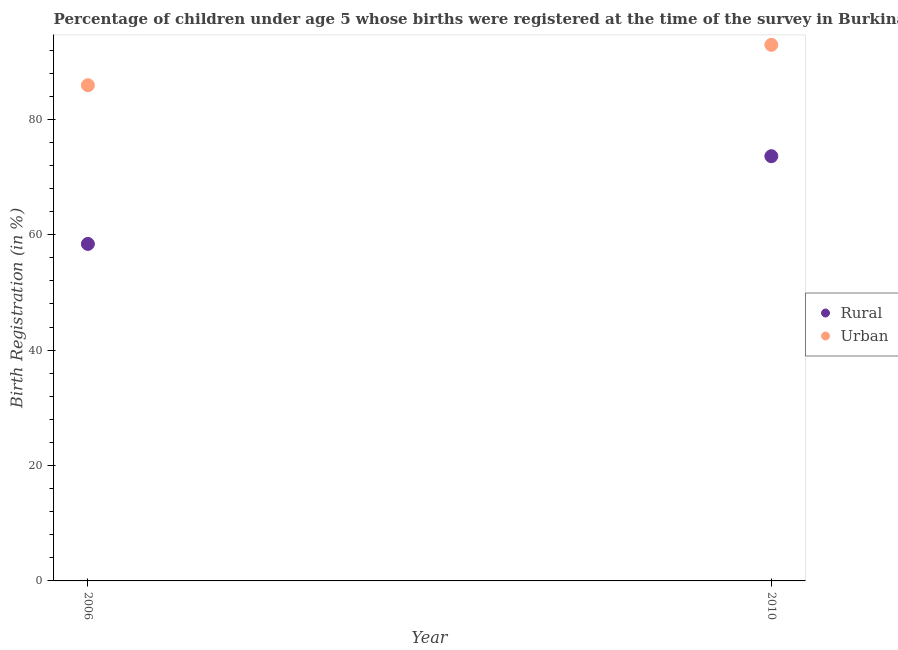Is the number of dotlines equal to the number of legend labels?
Your response must be concise. Yes. What is the urban birth registration in 2006?
Keep it short and to the point. 85.9. Across all years, what is the maximum urban birth registration?
Offer a terse response. 92.9. Across all years, what is the minimum urban birth registration?
Give a very brief answer. 85.9. What is the total rural birth registration in the graph?
Ensure brevity in your answer.  132. What is the difference between the urban birth registration in 2006 and that in 2010?
Your response must be concise. -7. What is the difference between the rural birth registration in 2010 and the urban birth registration in 2006?
Make the answer very short. -12.3. What is the average urban birth registration per year?
Your answer should be very brief. 89.4. In the year 2006, what is the difference between the urban birth registration and rural birth registration?
Offer a very short reply. 27.5. In how many years, is the urban birth registration greater than 80 %?
Give a very brief answer. 2. What is the ratio of the rural birth registration in 2006 to that in 2010?
Provide a succinct answer. 0.79. Is the urban birth registration in 2006 less than that in 2010?
Your answer should be very brief. Yes. In how many years, is the urban birth registration greater than the average urban birth registration taken over all years?
Offer a very short reply. 1. Does the rural birth registration monotonically increase over the years?
Offer a terse response. Yes. Is the urban birth registration strictly greater than the rural birth registration over the years?
Provide a succinct answer. Yes. Is the rural birth registration strictly less than the urban birth registration over the years?
Offer a terse response. Yes. How many dotlines are there?
Give a very brief answer. 2. How many legend labels are there?
Your answer should be very brief. 2. How are the legend labels stacked?
Provide a succinct answer. Vertical. What is the title of the graph?
Your answer should be compact. Percentage of children under age 5 whose births were registered at the time of the survey in Burkina Faso. What is the label or title of the X-axis?
Offer a terse response. Year. What is the label or title of the Y-axis?
Offer a very short reply. Birth Registration (in %). What is the Birth Registration (in %) in Rural in 2006?
Offer a terse response. 58.4. What is the Birth Registration (in %) in Urban in 2006?
Offer a terse response. 85.9. What is the Birth Registration (in %) in Rural in 2010?
Ensure brevity in your answer.  73.6. What is the Birth Registration (in %) of Urban in 2010?
Offer a very short reply. 92.9. Across all years, what is the maximum Birth Registration (in %) of Rural?
Keep it short and to the point. 73.6. Across all years, what is the maximum Birth Registration (in %) in Urban?
Give a very brief answer. 92.9. Across all years, what is the minimum Birth Registration (in %) of Rural?
Make the answer very short. 58.4. Across all years, what is the minimum Birth Registration (in %) in Urban?
Offer a terse response. 85.9. What is the total Birth Registration (in %) in Rural in the graph?
Your response must be concise. 132. What is the total Birth Registration (in %) in Urban in the graph?
Make the answer very short. 178.8. What is the difference between the Birth Registration (in %) in Rural in 2006 and that in 2010?
Provide a succinct answer. -15.2. What is the difference between the Birth Registration (in %) of Urban in 2006 and that in 2010?
Your answer should be compact. -7. What is the difference between the Birth Registration (in %) of Rural in 2006 and the Birth Registration (in %) of Urban in 2010?
Keep it short and to the point. -34.5. What is the average Birth Registration (in %) of Urban per year?
Keep it short and to the point. 89.4. In the year 2006, what is the difference between the Birth Registration (in %) of Rural and Birth Registration (in %) of Urban?
Ensure brevity in your answer.  -27.5. In the year 2010, what is the difference between the Birth Registration (in %) in Rural and Birth Registration (in %) in Urban?
Provide a short and direct response. -19.3. What is the ratio of the Birth Registration (in %) in Rural in 2006 to that in 2010?
Offer a terse response. 0.79. What is the ratio of the Birth Registration (in %) in Urban in 2006 to that in 2010?
Ensure brevity in your answer.  0.92. 